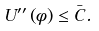Convert formula to latex. <formula><loc_0><loc_0><loc_500><loc_500>U ^ { \prime \prime } \left ( \phi \right ) \leq \bar { C } .</formula> 